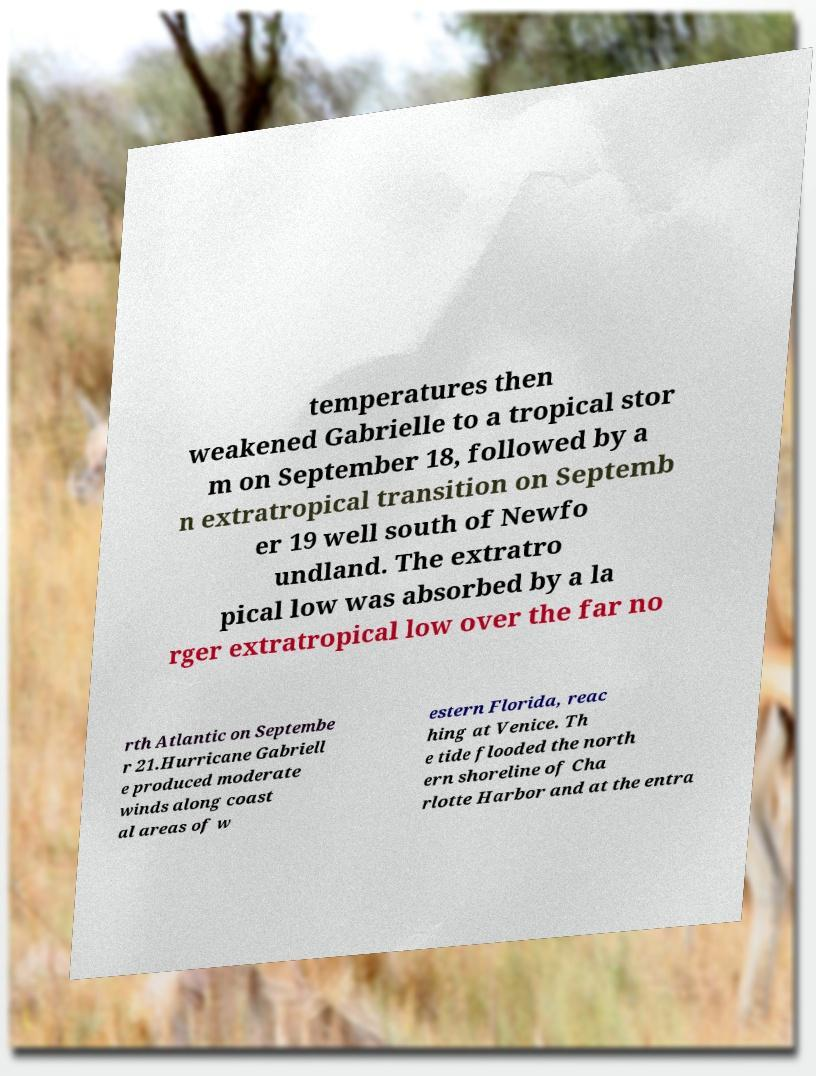Could you extract and type out the text from this image? temperatures then weakened Gabrielle to a tropical stor m on September 18, followed by a n extratropical transition on Septemb er 19 well south of Newfo undland. The extratro pical low was absorbed by a la rger extratropical low over the far no rth Atlantic on Septembe r 21.Hurricane Gabriell e produced moderate winds along coast al areas of w estern Florida, reac hing at Venice. Th e tide flooded the north ern shoreline of Cha rlotte Harbor and at the entra 